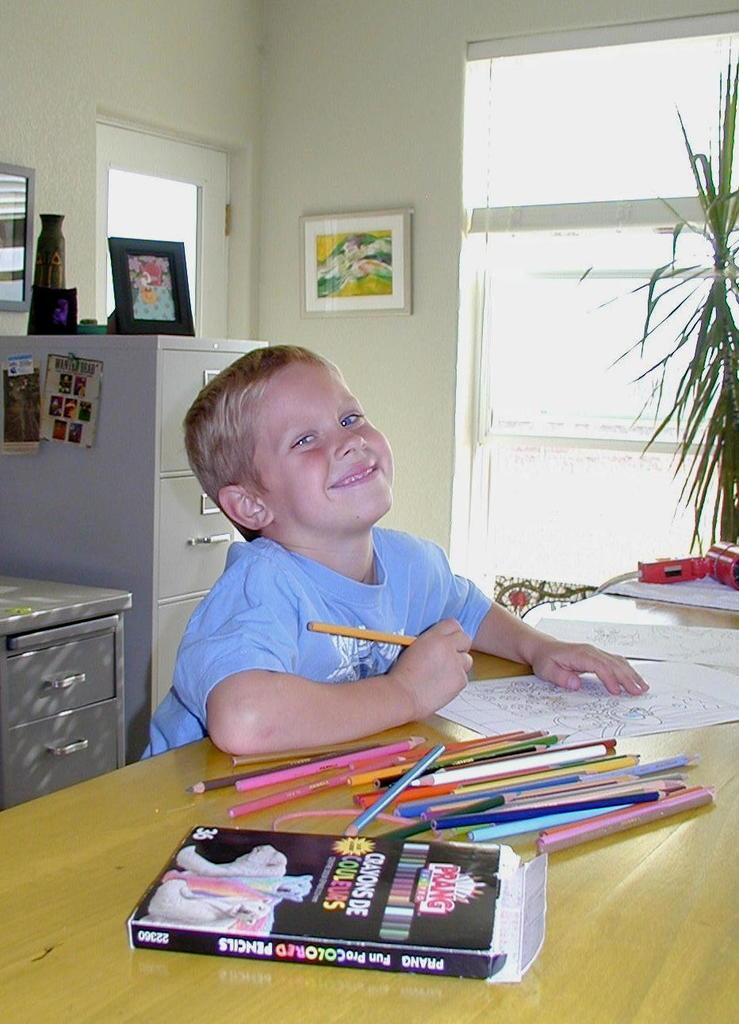What is the main subject of the image? The main subject of the image is a kid. What is the kid doing in the image? The kid is sitting on a chair and smiling. Where is the kid located in relation to the table? The kid is in front of a table. What items can be seen on the table? There are pencils and a box on the table. What type of brush is the kid using on the stage in the image? There is no brush or stage present in the image; it features a kid sitting in front of a table with pencils and a box. 